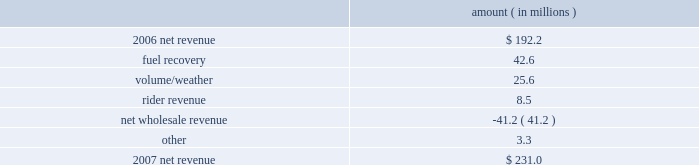Entergy new orleans , inc .
Management's financial discussion and analysis 2007 compared to 2006 net revenue consists of operating revenues net of : 1 ) fuel , fuel-related expenses , and gas purchased for resale , 2 ) purchased power expenses , and 3 ) other regulatory charges .
Following is an analysis of the change in net revenue comparing 2007 to 2006 .
Amount ( in millions ) .
The fuel recovery variance is due to the inclusion of grand gulf costs in fuel recoveries effective july 1 , 2006 .
In june 2006 , the city council approved the recovery of grand gulf costs through the fuel adjustment clause , without a corresponding change in base rates ( a significant portion of grand gulf costs was previously recovered through base rates ) .
The volume/weather variance is due to an increase in electricity usage in the service territory in 2007 compared to the same period in 2006 .
The first quarter 2006 was affected by customer losses following hurricane katrina .
Entergy new orleans estimates that approximately 132000 electric customers and 86000 gas customers have returned and are taking service as of december 31 , 2007 , compared to approximately 95000 electric customers and 65000 gas customers as of december 31 , 2006 .
Billed retail electricity usage increased a total of 540 gwh compared to the same period in 2006 , an increase of 14% ( 14 % ) .
The rider revenue variance is due primarily to a storm reserve rider effective march 2007 as a result of the city council's approval of a settlement agreement in october 2006 .
The approved storm reserve has been set to collect $ 75 million over a ten-year period through the rider and the funds will be held in a restricted escrow account .
The settlement agreement is discussed in note 2 to the financial statements .
The net wholesale revenue variance is due to more energy available for resale in 2006 due to the decrease in retail usage caused by customer losses following hurricane katrina .
In addition , 2006 revenue includes the sales into the wholesale market of entergy new orleans' share of the output of grand gulf , pursuant to city council approval of measures proposed by entergy new orleans to address the reduction in entergy new orleans' retail customer usage caused by hurricane katrina and to provide revenue support for the costs of entergy new orleans' share of grand other income statement variances 2008 compared to 2007 other operation and maintenance expenses decreased primarily due to : a provision for storm-related bad debts of $ 11 million recorded in 2007 ; a decrease of $ 6.2 million in legal and professional fees ; a decrease of $ 3.4 million in employee benefit expenses ; and a decrease of $ 1.9 million in gas operations spending due to higher labor and material costs for reliability work in 2007. .
What percent of the net change in revenue between 2006 and 2007 was due to fuel recovery? 
Computations: (42.6 / (231.0 - 192.2))
Answer: 1.09794. 